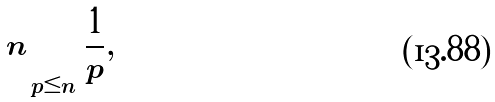<formula> <loc_0><loc_0><loc_500><loc_500>n \sum _ { p \leq n } { \frac { 1 } { p } } ,</formula> 